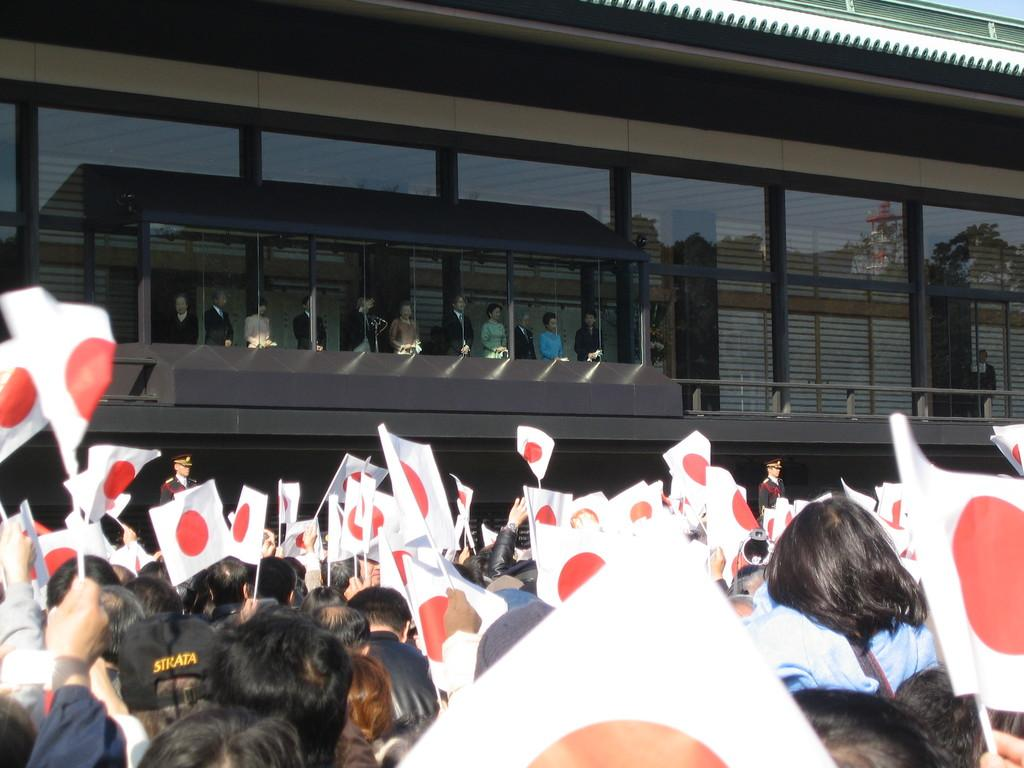What are the people in the image holding? The people in the image are holding flags. Where are the people located in the image? The people are standing near a glass inside a building. What are the people inside the building doing? The people inside the building are watching something. What type of fruit is being used as a weapon in the battle depicted in the image? There is no battle or fruit present in the image; it features people holding flags and watching something inside a building. 